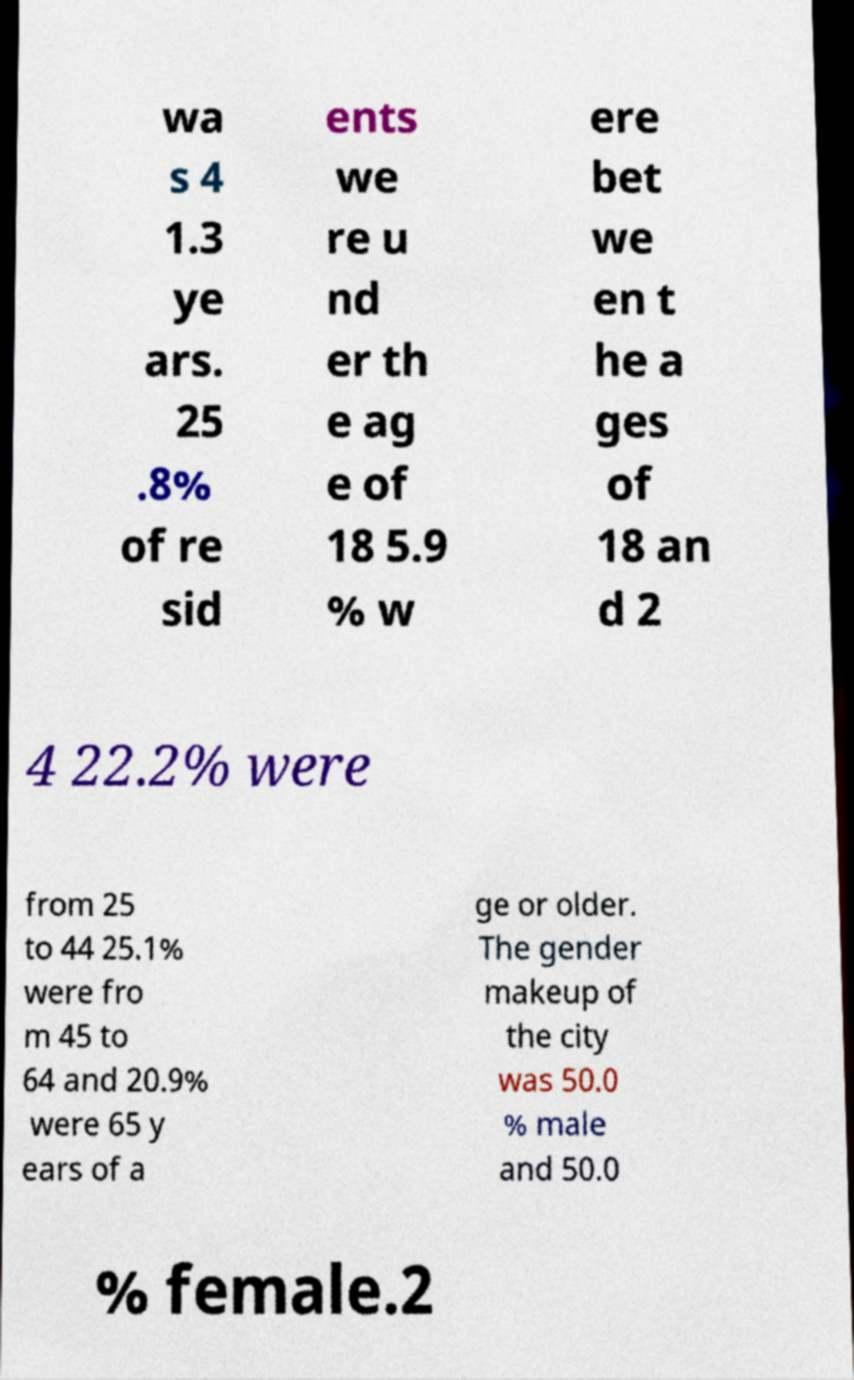I need the written content from this picture converted into text. Can you do that? wa s 4 1.3 ye ars. 25 .8% of re sid ents we re u nd er th e ag e of 18 5.9 % w ere bet we en t he a ges of 18 an d 2 4 22.2% were from 25 to 44 25.1% were fro m 45 to 64 and 20.9% were 65 y ears of a ge or older. The gender makeup of the city was 50.0 % male and 50.0 % female.2 